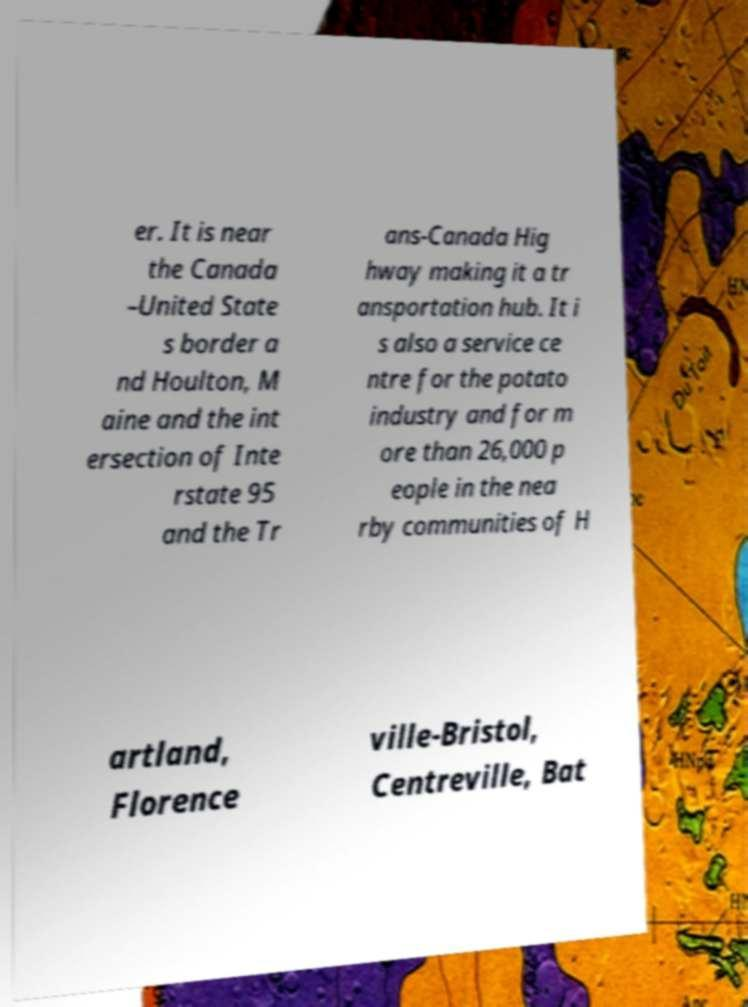Can you accurately transcribe the text from the provided image for me? er. It is near the Canada –United State s border a nd Houlton, M aine and the int ersection of Inte rstate 95 and the Tr ans-Canada Hig hway making it a tr ansportation hub. It i s also a service ce ntre for the potato industry and for m ore than 26,000 p eople in the nea rby communities of H artland, Florence ville-Bristol, Centreville, Bat 